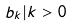Convert formula to latex. <formula><loc_0><loc_0><loc_500><loc_500>b _ { k } | k > 0</formula> 